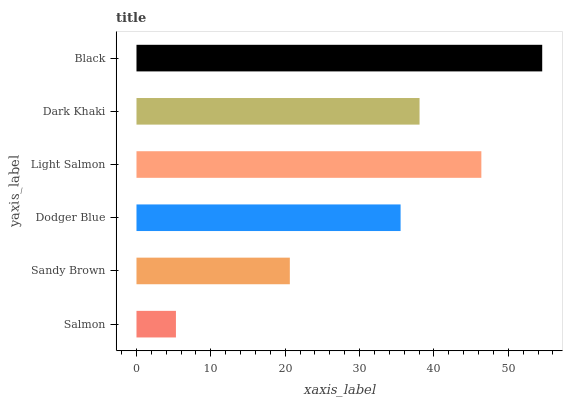Is Salmon the minimum?
Answer yes or no. Yes. Is Black the maximum?
Answer yes or no. Yes. Is Sandy Brown the minimum?
Answer yes or no. No. Is Sandy Brown the maximum?
Answer yes or no. No. Is Sandy Brown greater than Salmon?
Answer yes or no. Yes. Is Salmon less than Sandy Brown?
Answer yes or no. Yes. Is Salmon greater than Sandy Brown?
Answer yes or no. No. Is Sandy Brown less than Salmon?
Answer yes or no. No. Is Dark Khaki the high median?
Answer yes or no. Yes. Is Dodger Blue the low median?
Answer yes or no. Yes. Is Sandy Brown the high median?
Answer yes or no. No. Is Dark Khaki the low median?
Answer yes or no. No. 